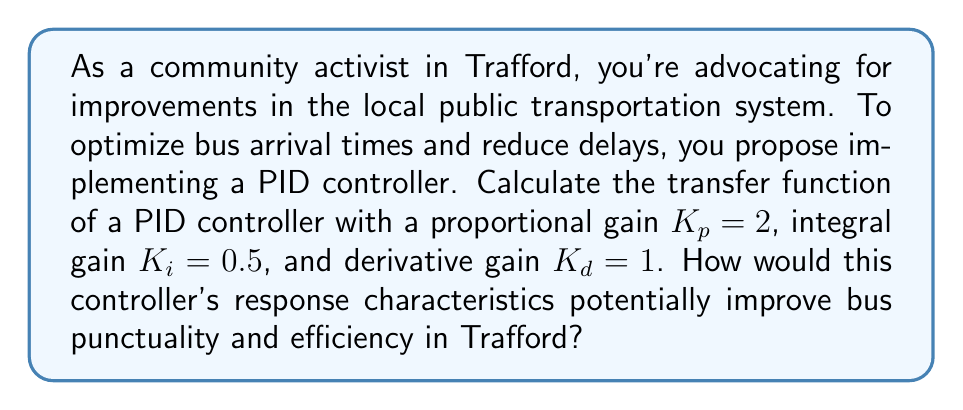Help me with this question. To calculate the transfer function of a PID controller, we need to understand its components and how they work together:

1. Proportional (P) term: $K_p \cdot e(t)$
2. Integral (I) term: $K_i \int_0^t e(\tau) d\tau$
3. Derivative (D) term: $K_d \frac{de(t)}{dt}$

Where $e(t)$ is the error signal (difference between desired and actual bus arrival times).

The time-domain equation for a PID controller is:

$$u(t) = K_p \cdot e(t) + K_i \int_0^t e(\tau) d\tau + K_d \frac{de(t)}{dt}$$

To obtain the transfer function, we need to convert this to the Laplace domain:

1. $\mathcal{L}\{e(t)\} = E(s)$
2. $\mathcal{L}\{\int_0^t e(\tau) d\tau\} = \frac{1}{s}E(s)$
3. $\mathcal{L}\{\frac{de(t)}{dt}\} = sE(s)$

The transfer function $G_{PID}(s)$ is the ratio of the controller output $U(s)$ to the error input $E(s)$ in the Laplace domain:

$$G_{PID}(s) = \frac{U(s)}{E(s)} = K_p + \frac{K_i}{s} + K_d s$$

Substituting the given values:

$$G_{PID}(s) = 2 + \frac{0.5}{s} + 1s$$

This can be written as:

$$G_{PID}(s) = \frac{2s^2 + s + 0.5}{s}$$

The characteristics of this PID controller would potentially improve bus punctuality and efficiency in Trafford by:

1. Proportional term (2): Providing a quick response to current errors in bus arrival times.
2. Integral term (0.5/s): Eliminating steady-state errors and ensuring long-term accuracy in bus schedules.
3. Derivative term (s): Anticipating future errors and helping to prevent overshooting or oscillations in bus arrival times.

This balanced approach would help maintain consistent bus schedules, reduce waiting times for passengers, and improve overall public transportation efficiency in Trafford.
Answer: The transfer function of the PID controller is:

$$G_{PID}(s) = \frac{2s^2 + s + 0.5}{s}$$ 